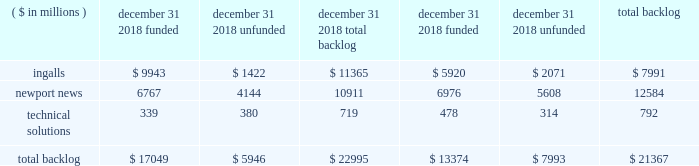December 2016 acquisition of camber and higher volumes in fleet support and oil and gas services , partially offset by lower nuclear and environmental volumes due to the resolution in 2016 of outstanding contract changes on a nuclear and environmental commercial contract .
Segment operating income 2018 - operating income in the technical solutions segment for the year ended december 31 , 2018 , was $ 32 million , compared to operating income of $ 21 million in 2017 .
The increase was primarily due to an allowance for accounts receivable in 2017 on a nuclear and environmental commercial contract and higher income from operating investments at our nuclear and environmental joint ventures , partially offset by one time employee bonus payments in 2018 related to the tax act and lower performance in fleet support services .
2017 - operating income in the technical solutions segment for the year ended december 31 , 2017 , was $ 21 million , compared to operating income of $ 8 million in 2016 .
The increase was primarily due to improved performance in oil and gas services and higher volume in mdis services following the december 2016 acquisition of camber , partially offset by the establishment of an allowance for accounts receivable on a nuclear and environmental commercial contract in 2017 and the resolution in 2016 of outstanding contract changes on a nuclear and environmental commercial contract .
Backlog total backlog as of december 31 , 2018 , was approximately $ 23 billion .
Total backlog includes both funded backlog ( firm orders for which funding is contractually obligated by the customer ) and unfunded backlog ( firm orders for which funding is not currently contractually obligated by the customer ) .
Backlog excludes unexercised contract options and unfunded idiq orders .
For contracts having no stated contract values , backlog includes only the amounts committed by the customer .
The table presents funded and unfunded backlog by segment as of december 31 , 2018 and 2017: .
We expect approximately 30% ( 30 % ) of the $ 23 billion total backlog as of december 31 , 2018 , to be converted into sales in 2019 .
U.s .
Government orders comprised substantially all of the backlog as of december 31 , 2018 and 2017 .
Awards 2018 - the value of new contract awards during the year ended december 31 , 2018 , was approximately $ 9.8 billion .
Significant new awards during the period included contracts for the construction of three arleigh burke class ( ddg 51 ) destroyers , for the detail design and construction of richard m .
Mccool jr .
( lpd 29 ) , for procurement of long-lead-time material for enterprise ( cvn 80 ) , and for the construction of nsc 10 ( unnamed ) and nsc 11 ( unnamed ) .
In addition , we received awards in 2019 valued at $ 15.2 billion for detail design and construction of the gerald r .
Ford class ( cvn 78 ) aircraft carriers enterprise ( cvn 80 ) and cvn 81 ( unnamed ) .
2017 - the value of new contract awards during the year ended december 31 , 2017 , was approximately $ 8.1 billion .
Significant new awards during this period included the detailed design and construction contract for bougainville ( lha 8 ) and the execution contract for the rcoh of uss george washington ( cvn 73 ) . .
What is the percent of ingalls backlog to the total sum of the backlogs? 
Computations: (7991 / 21367)
Answer: 0.37399. 